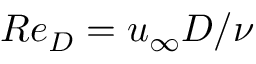<formula> <loc_0><loc_0><loc_500><loc_500>R e _ { D } = u _ { \infty } D / \nu</formula> 